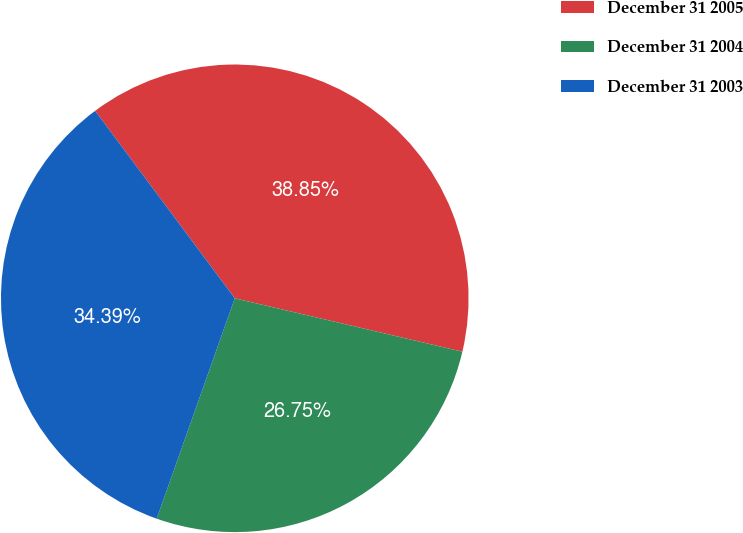Convert chart. <chart><loc_0><loc_0><loc_500><loc_500><pie_chart><fcel>December 31 2005<fcel>December 31 2004<fcel>December 31 2003<nl><fcel>38.85%<fcel>26.75%<fcel>34.39%<nl></chart> 